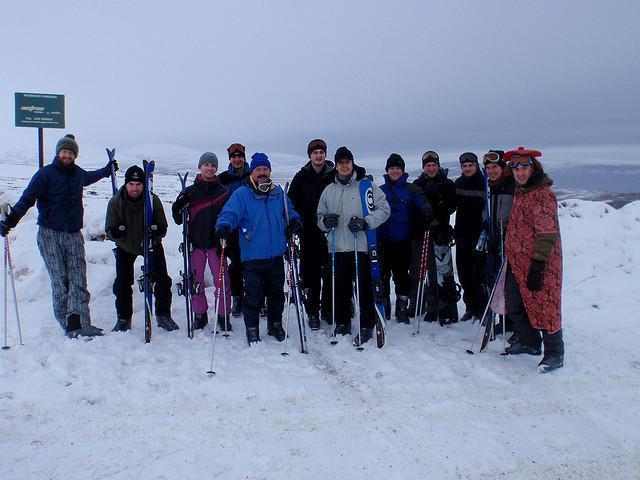How many people are posing?
Give a very brief answer. 12. How many people are in the photo?
Give a very brief answer. 12. How many people are standing for photograph?
Give a very brief answer. 12. How many people are there?
Give a very brief answer. 12. How many toilets have a colored seat?
Give a very brief answer. 0. 